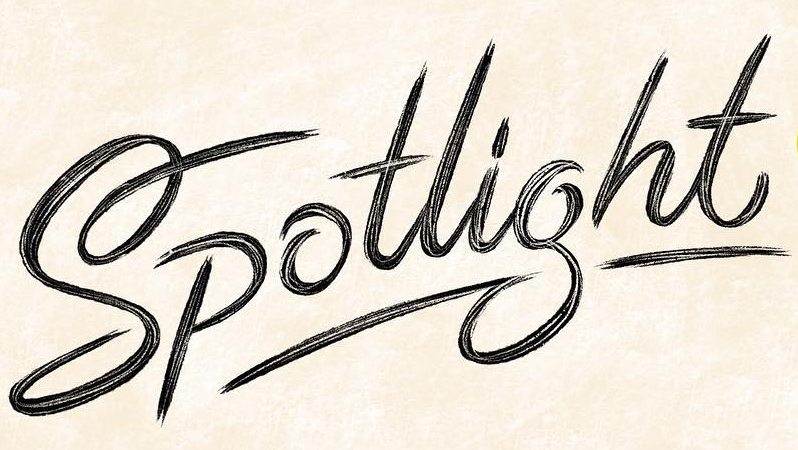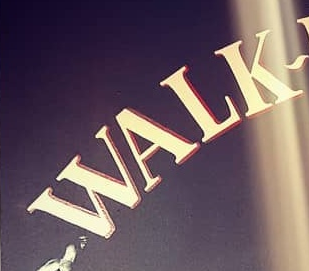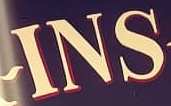What words are shown in these images in order, separated by a semicolon? Spotlight; WALK; INS 